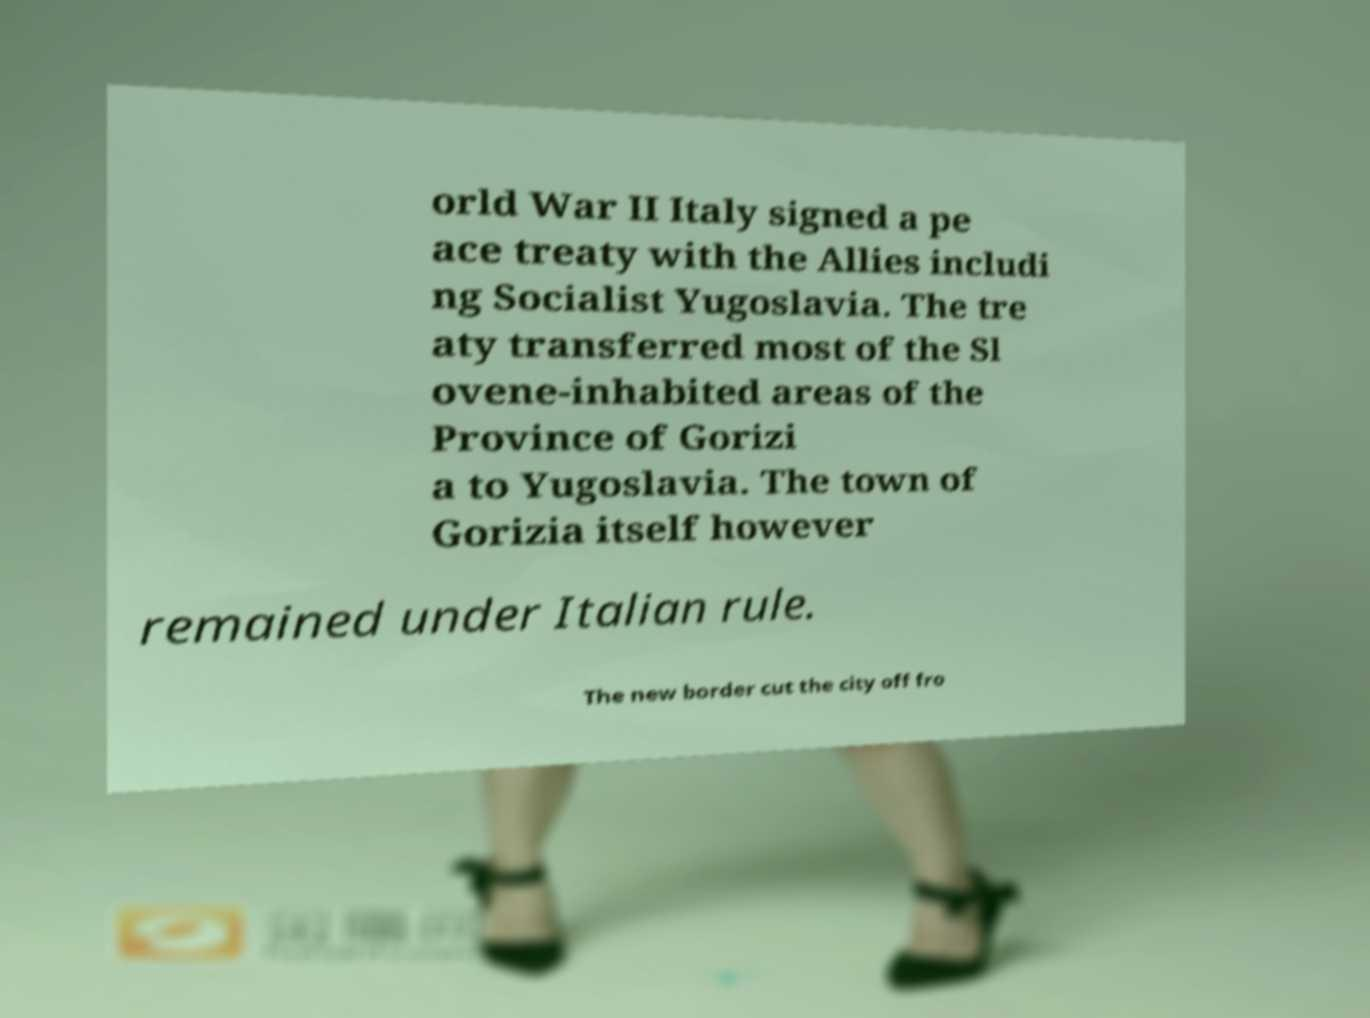What messages or text are displayed in this image? I need them in a readable, typed format. orld War II Italy signed a pe ace treaty with the Allies includi ng Socialist Yugoslavia. The tre aty transferred most of the Sl ovene-inhabited areas of the Province of Gorizi a to Yugoslavia. The town of Gorizia itself however remained under Italian rule. The new border cut the city off fro 